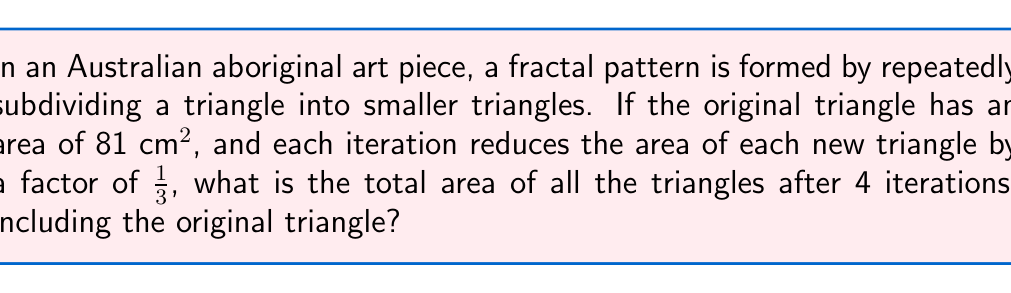Give your solution to this math problem. Let's approach this step-by-step:

1) First, we need to understand the pattern:
   - Iteration 0: The original triangle with area 81 cm²
   - Iteration 1: 3 new triangles, each 1/3 the area of the original
   - Iteration 2: 9 new triangles, each 1/9 the area of the original
   - And so on...

2) Let's calculate the area added at each iteration:
   - Iteration 0: $A_0 = 81$ cm²
   - Iteration 1: $A_1 = 81 \cdot 3 \cdot \frac{1}{3} = 81$ cm²
   - Iteration 2: $A_2 = 81 \cdot 9 \cdot \frac{1}{9} = 81$ cm²
   - Iteration 3: $A_3 = 81 \cdot 27 \cdot \frac{1}{27} = 81$ cm²
   - Iteration 4: $A_4 = 81 \cdot 81 \cdot \frac{1}{81} = 81$ cm²

3) We can see that each iteration adds 81 cm² to the total area.

4) Since we're including the original triangle and 4 iterations, we need to sum 5 times 81 cm²:

   $A_{total} = 81 \cdot 5 = 405$ cm²

This fractal pattern, where the total area increases linearly with each iteration despite the individual triangles getting smaller, is reminiscent of the Sierpinski triangle, a famous fractal that appears in various forms in Aboriginal Australian art.
Answer: 405 cm² 